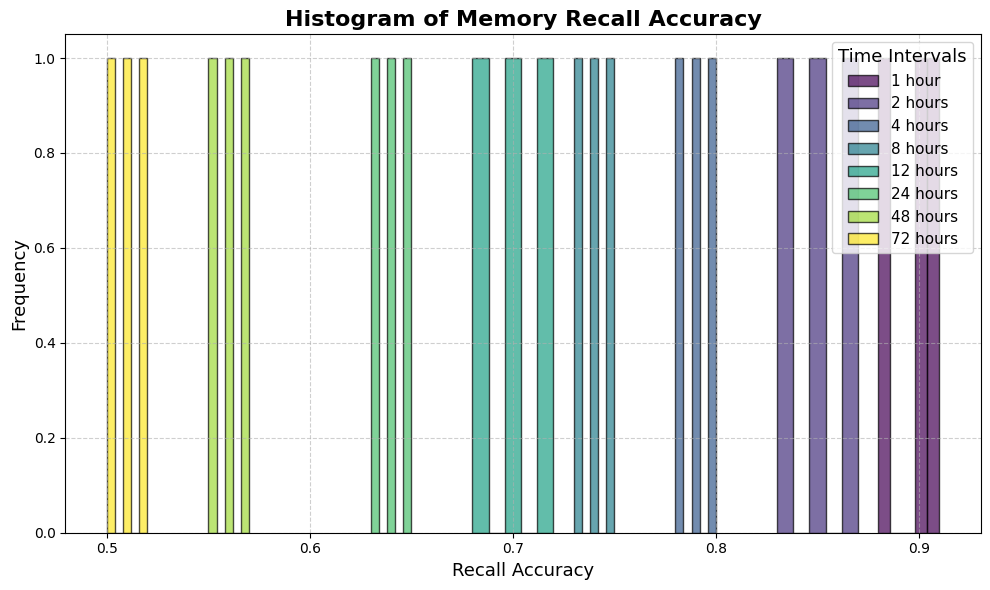What time interval has the highest recall accuracy? The histogram shows the frequency of different recall accuracies for each time interval. By identifying the tallest bars for each interval, we can see that the highest recall accuracy occurs in the 1_hour interval.
Answer: 1 hour Which time interval has the lowest median recall accuracy? To determine this, visually estimate the median in each histogram (the middle value). The interval with the lowest median recall accuracy is 72_hours.
Answer: 72 hours How does the highest recall accuracy in the 8_hours interval compare to the highest recall accuracy in the 12_hours interval? The highest recall accuracy in the 8_hours interval corresponds to the tallest bar in that interval's histogram, which is approximately 0.75. For the 12_hours interval, the highest is approximately 0.72. Therefore, 8_hours has a slightly higher maximum recall accuracy than 12_hours.
Answer: Higher What is the range of recall accuracy values for the 4_hours interval? To find the range, identify the lowest and highest recall accuracy values in the 4_hours histogram. The lowest is around 0.78 and the highest is around 0.80, so the range is 0.80 - 0.78 = 0.02.
Answer: 0.02 Which interval shows the most spread in recall accuracy values? The most spread (variation) in recall accuracy values can be identified by observing the width of the histogram bins for each time interval. The 24_hours interval shows a broad distribution from 0.63 to 0.65.
Answer: 24 hours Is the average recall accuracy lower at 48_hours or 72_hours? Visually comparing the bar heights for 48_hours and 72_hours, the recall accuracies in both intervals are low, but more so for 72_hours. To confirm, average the middle values of each histogram. 48_hours: (0.55+0.56+0.57)/3 = 0.56. 72_hours: (0.50+0.51+0.52)/3 = 0.51. So, 72_hours is lower.
Answer: 72 hours What does the color variation in the histogram bins represent? The color of each bin in the histogram represents different time intervals post-learning. This subtle difference in hue helps distinguish between the recall accuracy distributions of each interval.
Answer: Time intervals How does the recall accuracy change over time intervals based on this histogram? By visually observing the histogram bars from left to right (increasing time), recall accuracy gradually decreases over time. This is evident as the tallest bars (higher frequency of higher accuracy) shift from right to left in the histogram, starting from 1 hour to 72 hours.
Answer: Decreases In which interval do the majority of data points have recall accuracy around 0.90? Observing the histogram, the 1_hour interval consistently shows bars close to the 0.90 mark, indicating the majority of data points have recall accuracy around 0.90.
Answer: 1 hour 